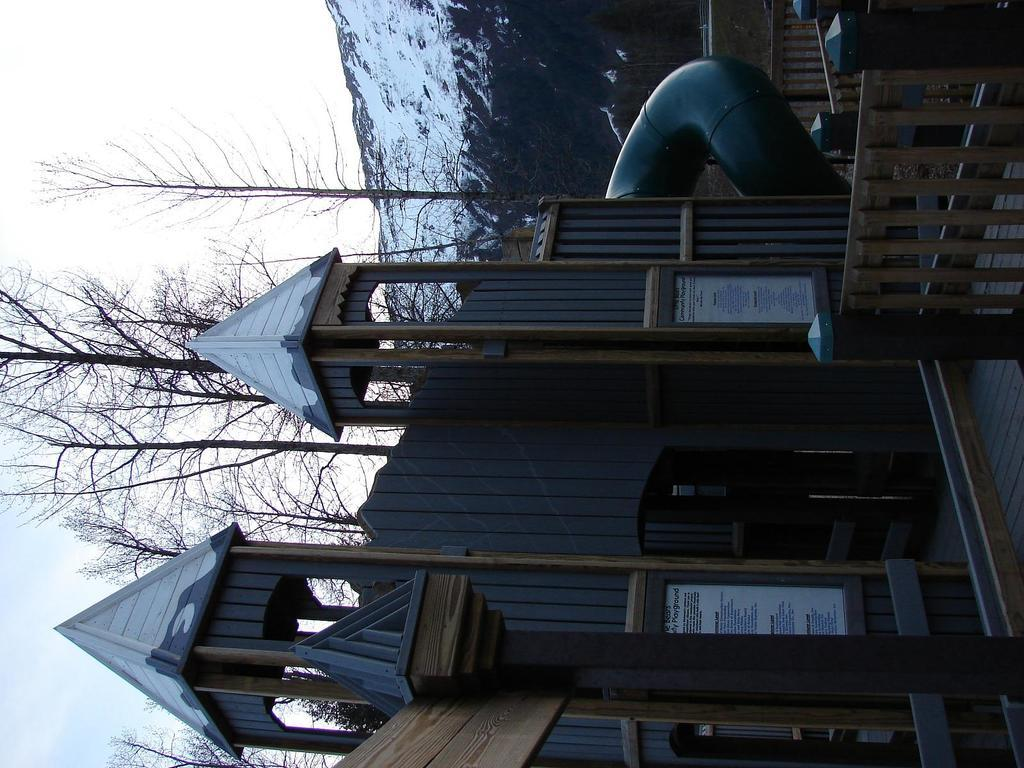What type of structure is visible in the image? There is a building in the image. What can be seen on the right side of the image? There is a fence and pipes on the right side of the image. What is visible in the background of the image? There are trees and mountains in the background of the image. What part of the sky is visible in the image? The sky is visible on the left side of the image. How many hands are visible in the image? There are no hands visible in the image. What type of airplane can be seen flying in the background of the image? There is no airplane present in the image; it only features a building, fence, pipes, trees, mountains, and the sky. 